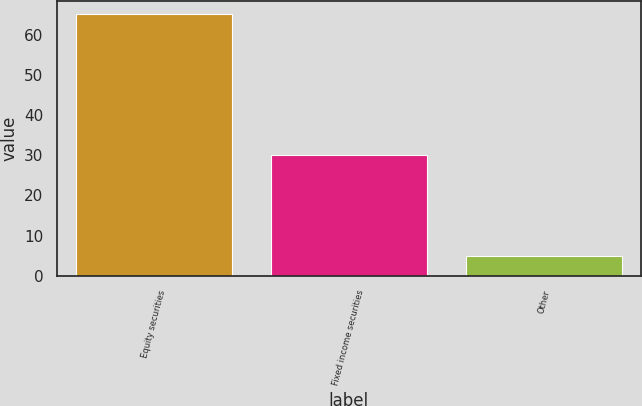Convert chart to OTSL. <chart><loc_0><loc_0><loc_500><loc_500><bar_chart><fcel>Equity securities<fcel>Fixed income securities<fcel>Other<nl><fcel>65<fcel>30<fcel>5<nl></chart> 